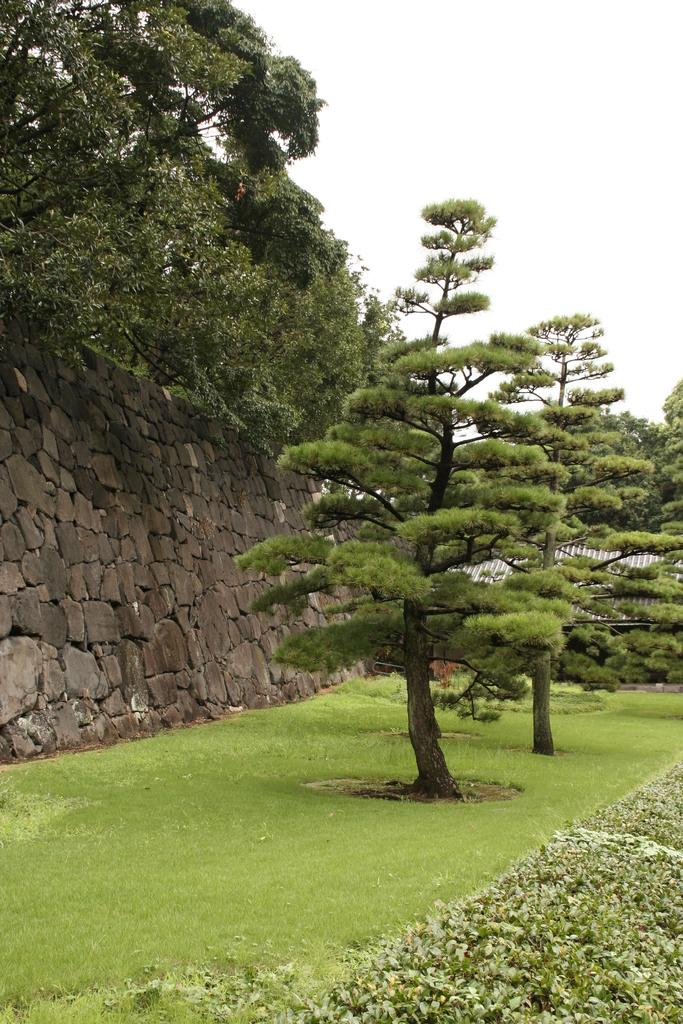What type of vegetation can be seen in the image? There are trees, plants, and grass visible in the image. Where is the wall located in the image? The wall is on the left side of the image. What is visible at the top of the image? The sky is visible at the top of the image. How many cakes are being shared between the plants in the image? There are no cakes present in the image; it features trees, plants, grass, a wall, and the sky. What is the relation between the trees and the wall in the image? There is no direct relation between the trees and the wall in the image; they are simply separate elements within the scene. 